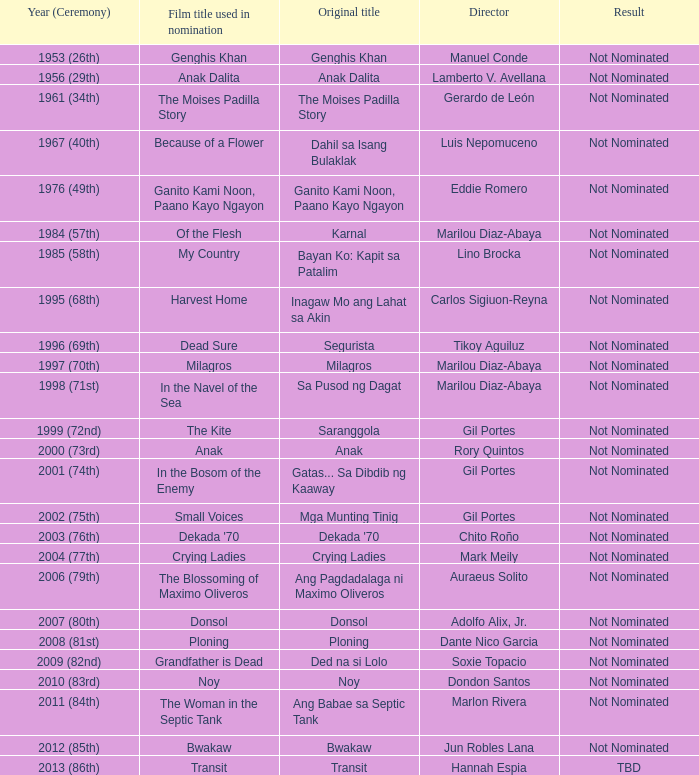What is the year when not nominated was the result, and In the Navel of the Sea was the film title used in nomination? 1998 (71st). 